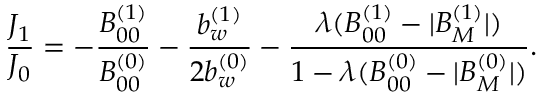<formula> <loc_0><loc_0><loc_500><loc_500>\frac { J _ { 1 } } { J _ { 0 } } = - \frac { B _ { 0 0 } ^ { ( 1 ) } } { B _ { 0 0 } ^ { ( 0 ) } } - \frac { b _ { w } ^ { ( 1 ) } } { 2 b _ { w } ^ { ( 0 ) } } - \frac { \lambda ( B _ { 0 0 } ^ { ( 1 ) } - | B _ { M } ^ { ( 1 ) } | ) } { 1 - \lambda ( B _ { 0 0 } ^ { ( 0 ) } - | B _ { M } ^ { ( 0 ) } | ) } .</formula> 